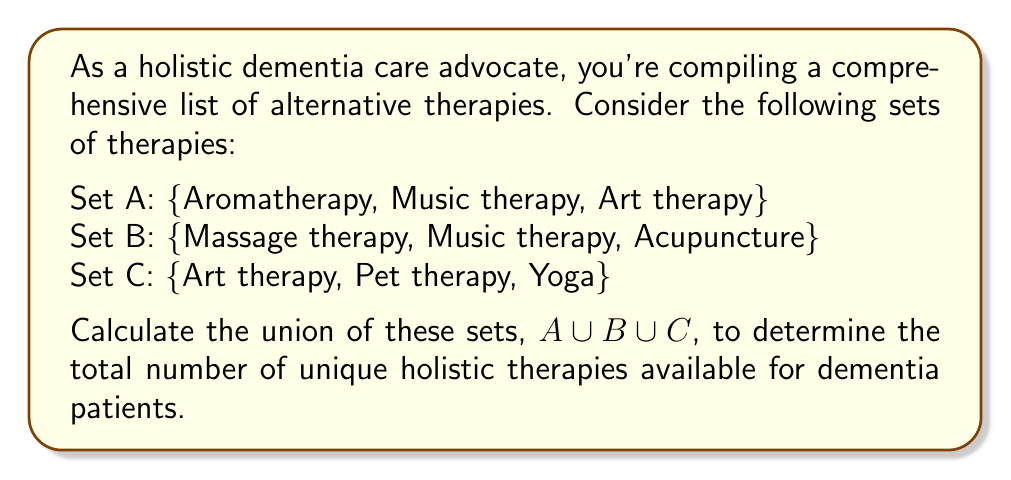Help me with this question. To solve this problem, we need to find the union of sets A, B, and C. The union of sets includes all unique elements from all sets, without duplicates.

Let's break it down step-by-step:

1. List all elements from set A:
   {Aromatherapy, Music therapy, Art therapy}

2. Add unique elements from set B:
   Music therapy is already included, so we only add:
   {Aromatherapy, Music therapy, Art therapy, Massage therapy, Acupuncture}

3. Add unique elements from set C:
   Art therapy is already included, so we only add:
   {Aromatherapy, Music therapy, Art therapy, Massage therapy, Acupuncture, Pet therapy, Yoga}

4. Count the total number of unique elements in the resulting set:
   $|A \cup B \cup C| = 7$

The union operation can be represented mathematically as:

$$A \cup B \cup C = \{x : x \in A \text{ or } x \in B \text{ or } x \in C\}$$

Where $x$ represents each therapy in the combined set.
Answer: The union of sets A, B, and C contains 7 unique holistic therapies for dementia care. 